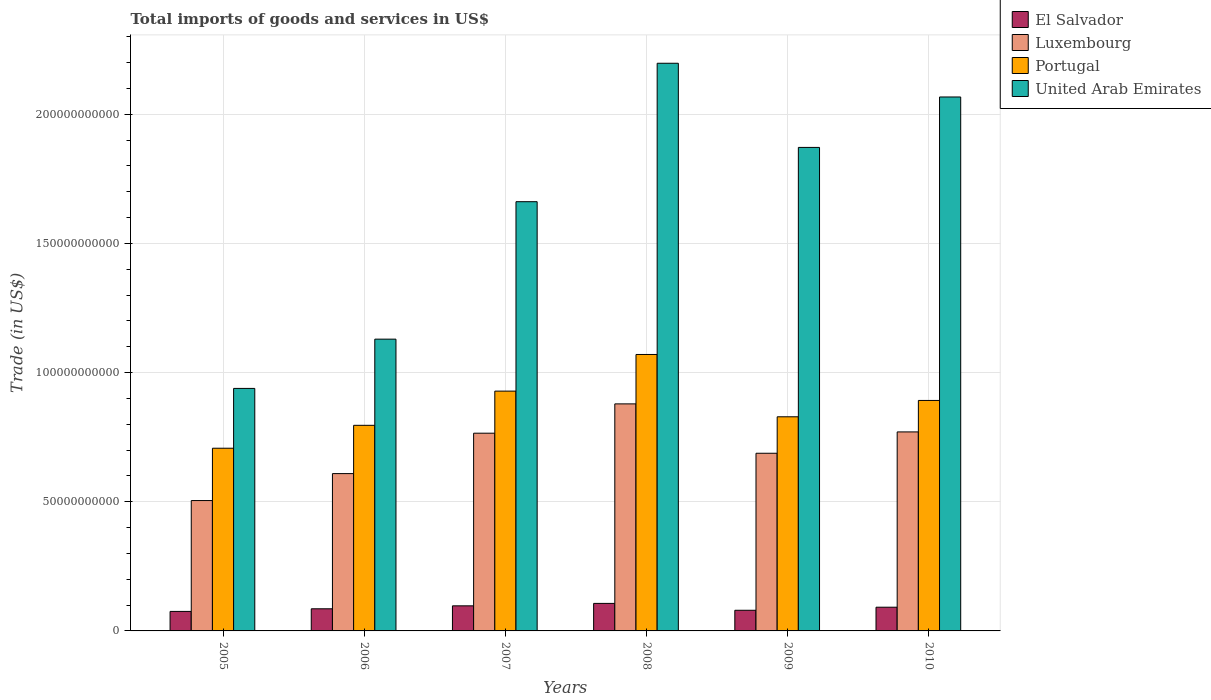How many different coloured bars are there?
Your response must be concise. 4. Are the number of bars per tick equal to the number of legend labels?
Keep it short and to the point. Yes. What is the label of the 4th group of bars from the left?
Ensure brevity in your answer.  2008. What is the total imports of goods and services in United Arab Emirates in 2007?
Offer a terse response. 1.66e+11. Across all years, what is the maximum total imports of goods and services in Luxembourg?
Your answer should be compact. 8.79e+1. Across all years, what is the minimum total imports of goods and services in United Arab Emirates?
Offer a terse response. 9.39e+1. In which year was the total imports of goods and services in United Arab Emirates maximum?
Your answer should be very brief. 2008. In which year was the total imports of goods and services in El Salvador minimum?
Offer a very short reply. 2005. What is the total total imports of goods and services in Luxembourg in the graph?
Provide a short and direct response. 4.22e+11. What is the difference between the total imports of goods and services in United Arab Emirates in 2006 and that in 2007?
Offer a very short reply. -5.32e+1. What is the difference between the total imports of goods and services in Portugal in 2007 and the total imports of goods and services in Luxembourg in 2010?
Offer a very short reply. 1.58e+1. What is the average total imports of goods and services in United Arab Emirates per year?
Provide a short and direct response. 1.64e+11. In the year 2005, what is the difference between the total imports of goods and services in United Arab Emirates and total imports of goods and services in Luxembourg?
Your response must be concise. 4.34e+1. What is the ratio of the total imports of goods and services in Luxembourg in 2009 to that in 2010?
Your answer should be very brief. 0.89. What is the difference between the highest and the second highest total imports of goods and services in Portugal?
Provide a succinct answer. 1.42e+1. What is the difference between the highest and the lowest total imports of goods and services in Luxembourg?
Your response must be concise. 3.74e+1. In how many years, is the total imports of goods and services in United Arab Emirates greater than the average total imports of goods and services in United Arab Emirates taken over all years?
Provide a succinct answer. 4. Is it the case that in every year, the sum of the total imports of goods and services in Portugal and total imports of goods and services in Luxembourg is greater than the sum of total imports of goods and services in El Salvador and total imports of goods and services in United Arab Emirates?
Your response must be concise. No. What does the 4th bar from the left in 2010 represents?
Your answer should be very brief. United Arab Emirates. What does the 2nd bar from the right in 2007 represents?
Give a very brief answer. Portugal. Is it the case that in every year, the sum of the total imports of goods and services in United Arab Emirates and total imports of goods and services in El Salvador is greater than the total imports of goods and services in Portugal?
Provide a short and direct response. Yes. Are all the bars in the graph horizontal?
Your response must be concise. No. What is the difference between two consecutive major ticks on the Y-axis?
Offer a terse response. 5.00e+1. Are the values on the major ticks of Y-axis written in scientific E-notation?
Give a very brief answer. No. Does the graph contain any zero values?
Your response must be concise. No. Does the graph contain grids?
Keep it short and to the point. Yes. How many legend labels are there?
Your answer should be compact. 4. How are the legend labels stacked?
Ensure brevity in your answer.  Vertical. What is the title of the graph?
Give a very brief answer. Total imports of goods and services in US$. Does "Togo" appear as one of the legend labels in the graph?
Provide a succinct answer. No. What is the label or title of the X-axis?
Offer a terse response. Years. What is the label or title of the Y-axis?
Keep it short and to the point. Trade (in US$). What is the Trade (in US$) of El Salvador in 2005?
Your response must be concise. 7.55e+09. What is the Trade (in US$) of Luxembourg in 2005?
Give a very brief answer. 5.05e+1. What is the Trade (in US$) of Portugal in 2005?
Your answer should be compact. 7.07e+1. What is the Trade (in US$) in United Arab Emirates in 2005?
Offer a very short reply. 9.39e+1. What is the Trade (in US$) of El Salvador in 2006?
Make the answer very short. 8.56e+09. What is the Trade (in US$) in Luxembourg in 2006?
Ensure brevity in your answer.  6.09e+1. What is the Trade (in US$) of Portugal in 2006?
Your answer should be very brief. 7.96e+1. What is the Trade (in US$) of United Arab Emirates in 2006?
Ensure brevity in your answer.  1.13e+11. What is the Trade (in US$) of El Salvador in 2007?
Your response must be concise. 9.71e+09. What is the Trade (in US$) in Luxembourg in 2007?
Offer a terse response. 7.65e+1. What is the Trade (in US$) of Portugal in 2007?
Provide a short and direct response. 9.28e+1. What is the Trade (in US$) of United Arab Emirates in 2007?
Offer a terse response. 1.66e+11. What is the Trade (in US$) of El Salvador in 2008?
Give a very brief answer. 1.07e+1. What is the Trade (in US$) in Luxembourg in 2008?
Offer a very short reply. 8.79e+1. What is the Trade (in US$) in Portugal in 2008?
Your answer should be compact. 1.07e+11. What is the Trade (in US$) of United Arab Emirates in 2008?
Provide a succinct answer. 2.20e+11. What is the Trade (in US$) of El Salvador in 2009?
Your answer should be compact. 7.99e+09. What is the Trade (in US$) of Luxembourg in 2009?
Make the answer very short. 6.88e+1. What is the Trade (in US$) of Portugal in 2009?
Give a very brief answer. 8.29e+1. What is the Trade (in US$) of United Arab Emirates in 2009?
Offer a very short reply. 1.87e+11. What is the Trade (in US$) of El Salvador in 2010?
Provide a short and direct response. 9.18e+09. What is the Trade (in US$) in Luxembourg in 2010?
Give a very brief answer. 7.70e+1. What is the Trade (in US$) in Portugal in 2010?
Provide a succinct answer. 8.92e+1. What is the Trade (in US$) of United Arab Emirates in 2010?
Offer a very short reply. 2.07e+11. Across all years, what is the maximum Trade (in US$) of El Salvador?
Give a very brief answer. 1.07e+1. Across all years, what is the maximum Trade (in US$) of Luxembourg?
Give a very brief answer. 8.79e+1. Across all years, what is the maximum Trade (in US$) in Portugal?
Keep it short and to the point. 1.07e+11. Across all years, what is the maximum Trade (in US$) in United Arab Emirates?
Give a very brief answer. 2.20e+11. Across all years, what is the minimum Trade (in US$) in El Salvador?
Your response must be concise. 7.55e+09. Across all years, what is the minimum Trade (in US$) in Luxembourg?
Ensure brevity in your answer.  5.05e+1. Across all years, what is the minimum Trade (in US$) in Portugal?
Provide a succinct answer. 7.07e+1. Across all years, what is the minimum Trade (in US$) of United Arab Emirates?
Provide a short and direct response. 9.39e+1. What is the total Trade (in US$) of El Salvador in the graph?
Provide a short and direct response. 5.36e+1. What is the total Trade (in US$) in Luxembourg in the graph?
Provide a short and direct response. 4.22e+11. What is the total Trade (in US$) in Portugal in the graph?
Provide a short and direct response. 5.22e+11. What is the total Trade (in US$) in United Arab Emirates in the graph?
Provide a succinct answer. 9.86e+11. What is the difference between the Trade (in US$) of El Salvador in 2005 and that in 2006?
Ensure brevity in your answer.  -1.02e+09. What is the difference between the Trade (in US$) of Luxembourg in 2005 and that in 2006?
Provide a succinct answer. -1.04e+1. What is the difference between the Trade (in US$) in Portugal in 2005 and that in 2006?
Your answer should be compact. -8.87e+09. What is the difference between the Trade (in US$) of United Arab Emirates in 2005 and that in 2006?
Give a very brief answer. -1.91e+1. What is the difference between the Trade (in US$) of El Salvador in 2005 and that in 2007?
Your answer should be very brief. -2.16e+09. What is the difference between the Trade (in US$) of Luxembourg in 2005 and that in 2007?
Offer a very short reply. -2.61e+1. What is the difference between the Trade (in US$) in Portugal in 2005 and that in 2007?
Your response must be concise. -2.21e+1. What is the difference between the Trade (in US$) in United Arab Emirates in 2005 and that in 2007?
Keep it short and to the point. -7.23e+1. What is the difference between the Trade (in US$) of El Salvador in 2005 and that in 2008?
Keep it short and to the point. -3.10e+09. What is the difference between the Trade (in US$) in Luxembourg in 2005 and that in 2008?
Make the answer very short. -3.74e+1. What is the difference between the Trade (in US$) in Portugal in 2005 and that in 2008?
Make the answer very short. -3.63e+1. What is the difference between the Trade (in US$) in United Arab Emirates in 2005 and that in 2008?
Provide a short and direct response. -1.26e+11. What is the difference between the Trade (in US$) of El Salvador in 2005 and that in 2009?
Provide a succinct answer. -4.42e+08. What is the difference between the Trade (in US$) in Luxembourg in 2005 and that in 2009?
Your answer should be compact. -1.83e+1. What is the difference between the Trade (in US$) of Portugal in 2005 and that in 2009?
Keep it short and to the point. -1.22e+1. What is the difference between the Trade (in US$) in United Arab Emirates in 2005 and that in 2009?
Your answer should be compact. -9.33e+1. What is the difference between the Trade (in US$) in El Salvador in 2005 and that in 2010?
Offer a terse response. -1.63e+09. What is the difference between the Trade (in US$) in Luxembourg in 2005 and that in 2010?
Keep it short and to the point. -2.66e+1. What is the difference between the Trade (in US$) in Portugal in 2005 and that in 2010?
Make the answer very short. -1.85e+1. What is the difference between the Trade (in US$) in United Arab Emirates in 2005 and that in 2010?
Make the answer very short. -1.13e+11. What is the difference between the Trade (in US$) in El Salvador in 2006 and that in 2007?
Give a very brief answer. -1.15e+09. What is the difference between the Trade (in US$) in Luxembourg in 2006 and that in 2007?
Provide a succinct answer. -1.56e+1. What is the difference between the Trade (in US$) in Portugal in 2006 and that in 2007?
Provide a succinct answer. -1.32e+1. What is the difference between the Trade (in US$) in United Arab Emirates in 2006 and that in 2007?
Provide a short and direct response. -5.32e+1. What is the difference between the Trade (in US$) in El Salvador in 2006 and that in 2008?
Give a very brief answer. -2.09e+09. What is the difference between the Trade (in US$) in Luxembourg in 2006 and that in 2008?
Provide a succinct answer. -2.70e+1. What is the difference between the Trade (in US$) of Portugal in 2006 and that in 2008?
Your answer should be compact. -2.74e+1. What is the difference between the Trade (in US$) of United Arab Emirates in 2006 and that in 2008?
Offer a very short reply. -1.07e+11. What is the difference between the Trade (in US$) in El Salvador in 2006 and that in 2009?
Provide a succinct answer. 5.74e+08. What is the difference between the Trade (in US$) of Luxembourg in 2006 and that in 2009?
Your answer should be very brief. -7.87e+09. What is the difference between the Trade (in US$) in Portugal in 2006 and that in 2009?
Give a very brief answer. -3.30e+09. What is the difference between the Trade (in US$) in United Arab Emirates in 2006 and that in 2009?
Give a very brief answer. -7.42e+1. What is the difference between the Trade (in US$) of El Salvador in 2006 and that in 2010?
Offer a very short reply. -6.12e+08. What is the difference between the Trade (in US$) of Luxembourg in 2006 and that in 2010?
Keep it short and to the point. -1.61e+1. What is the difference between the Trade (in US$) of Portugal in 2006 and that in 2010?
Your answer should be very brief. -9.63e+09. What is the difference between the Trade (in US$) of United Arab Emirates in 2006 and that in 2010?
Your answer should be very brief. -9.37e+1. What is the difference between the Trade (in US$) of El Salvador in 2007 and that in 2008?
Make the answer very short. -9.41e+08. What is the difference between the Trade (in US$) of Luxembourg in 2007 and that in 2008?
Your answer should be very brief. -1.13e+1. What is the difference between the Trade (in US$) of Portugal in 2007 and that in 2008?
Ensure brevity in your answer.  -1.42e+1. What is the difference between the Trade (in US$) in United Arab Emirates in 2007 and that in 2008?
Your answer should be very brief. -5.36e+1. What is the difference between the Trade (in US$) of El Salvador in 2007 and that in 2009?
Keep it short and to the point. 1.72e+09. What is the difference between the Trade (in US$) of Luxembourg in 2007 and that in 2009?
Your answer should be very brief. 7.76e+09. What is the difference between the Trade (in US$) in Portugal in 2007 and that in 2009?
Your response must be concise. 9.94e+09. What is the difference between the Trade (in US$) of United Arab Emirates in 2007 and that in 2009?
Your answer should be very brief. -2.10e+1. What is the difference between the Trade (in US$) in El Salvador in 2007 and that in 2010?
Make the answer very short. 5.33e+08. What is the difference between the Trade (in US$) in Luxembourg in 2007 and that in 2010?
Keep it short and to the point. -4.96e+08. What is the difference between the Trade (in US$) of Portugal in 2007 and that in 2010?
Your answer should be compact. 3.61e+09. What is the difference between the Trade (in US$) in United Arab Emirates in 2007 and that in 2010?
Your answer should be compact. -4.05e+1. What is the difference between the Trade (in US$) of El Salvador in 2008 and that in 2009?
Give a very brief answer. 2.66e+09. What is the difference between the Trade (in US$) in Luxembourg in 2008 and that in 2009?
Provide a succinct answer. 1.91e+1. What is the difference between the Trade (in US$) in Portugal in 2008 and that in 2009?
Your answer should be compact. 2.41e+1. What is the difference between the Trade (in US$) in United Arab Emirates in 2008 and that in 2009?
Your answer should be compact. 3.26e+1. What is the difference between the Trade (in US$) in El Salvador in 2008 and that in 2010?
Your answer should be compact. 1.47e+09. What is the difference between the Trade (in US$) of Luxembourg in 2008 and that in 2010?
Provide a short and direct response. 1.09e+1. What is the difference between the Trade (in US$) in Portugal in 2008 and that in 2010?
Make the answer very short. 1.78e+1. What is the difference between the Trade (in US$) in United Arab Emirates in 2008 and that in 2010?
Provide a short and direct response. 1.31e+1. What is the difference between the Trade (in US$) in El Salvador in 2009 and that in 2010?
Offer a terse response. -1.19e+09. What is the difference between the Trade (in US$) of Luxembourg in 2009 and that in 2010?
Keep it short and to the point. -8.26e+09. What is the difference between the Trade (in US$) in Portugal in 2009 and that in 2010?
Provide a short and direct response. -6.33e+09. What is the difference between the Trade (in US$) of United Arab Emirates in 2009 and that in 2010?
Keep it short and to the point. -1.95e+1. What is the difference between the Trade (in US$) of El Salvador in 2005 and the Trade (in US$) of Luxembourg in 2006?
Your answer should be very brief. -5.33e+1. What is the difference between the Trade (in US$) in El Salvador in 2005 and the Trade (in US$) in Portugal in 2006?
Make the answer very short. -7.20e+1. What is the difference between the Trade (in US$) in El Salvador in 2005 and the Trade (in US$) in United Arab Emirates in 2006?
Make the answer very short. -1.05e+11. What is the difference between the Trade (in US$) of Luxembourg in 2005 and the Trade (in US$) of Portugal in 2006?
Ensure brevity in your answer.  -2.91e+1. What is the difference between the Trade (in US$) in Luxembourg in 2005 and the Trade (in US$) in United Arab Emirates in 2006?
Make the answer very short. -6.25e+1. What is the difference between the Trade (in US$) of Portugal in 2005 and the Trade (in US$) of United Arab Emirates in 2006?
Keep it short and to the point. -4.22e+1. What is the difference between the Trade (in US$) in El Salvador in 2005 and the Trade (in US$) in Luxembourg in 2007?
Offer a very short reply. -6.90e+1. What is the difference between the Trade (in US$) in El Salvador in 2005 and the Trade (in US$) in Portugal in 2007?
Offer a very short reply. -8.53e+1. What is the difference between the Trade (in US$) of El Salvador in 2005 and the Trade (in US$) of United Arab Emirates in 2007?
Your response must be concise. -1.59e+11. What is the difference between the Trade (in US$) of Luxembourg in 2005 and the Trade (in US$) of Portugal in 2007?
Keep it short and to the point. -4.24e+1. What is the difference between the Trade (in US$) in Luxembourg in 2005 and the Trade (in US$) in United Arab Emirates in 2007?
Your answer should be compact. -1.16e+11. What is the difference between the Trade (in US$) of Portugal in 2005 and the Trade (in US$) of United Arab Emirates in 2007?
Your answer should be compact. -9.54e+1. What is the difference between the Trade (in US$) in El Salvador in 2005 and the Trade (in US$) in Luxembourg in 2008?
Provide a succinct answer. -8.03e+1. What is the difference between the Trade (in US$) of El Salvador in 2005 and the Trade (in US$) of Portugal in 2008?
Offer a terse response. -9.94e+1. What is the difference between the Trade (in US$) in El Salvador in 2005 and the Trade (in US$) in United Arab Emirates in 2008?
Give a very brief answer. -2.12e+11. What is the difference between the Trade (in US$) of Luxembourg in 2005 and the Trade (in US$) of Portugal in 2008?
Keep it short and to the point. -5.65e+1. What is the difference between the Trade (in US$) of Luxembourg in 2005 and the Trade (in US$) of United Arab Emirates in 2008?
Provide a short and direct response. -1.69e+11. What is the difference between the Trade (in US$) of Portugal in 2005 and the Trade (in US$) of United Arab Emirates in 2008?
Your answer should be compact. -1.49e+11. What is the difference between the Trade (in US$) of El Salvador in 2005 and the Trade (in US$) of Luxembourg in 2009?
Your answer should be compact. -6.12e+1. What is the difference between the Trade (in US$) of El Salvador in 2005 and the Trade (in US$) of Portugal in 2009?
Offer a very short reply. -7.53e+1. What is the difference between the Trade (in US$) in El Salvador in 2005 and the Trade (in US$) in United Arab Emirates in 2009?
Provide a short and direct response. -1.80e+11. What is the difference between the Trade (in US$) of Luxembourg in 2005 and the Trade (in US$) of Portugal in 2009?
Make the answer very short. -3.24e+1. What is the difference between the Trade (in US$) of Luxembourg in 2005 and the Trade (in US$) of United Arab Emirates in 2009?
Your answer should be compact. -1.37e+11. What is the difference between the Trade (in US$) in Portugal in 2005 and the Trade (in US$) in United Arab Emirates in 2009?
Give a very brief answer. -1.16e+11. What is the difference between the Trade (in US$) in El Salvador in 2005 and the Trade (in US$) in Luxembourg in 2010?
Provide a succinct answer. -6.95e+1. What is the difference between the Trade (in US$) of El Salvador in 2005 and the Trade (in US$) of Portugal in 2010?
Your response must be concise. -8.17e+1. What is the difference between the Trade (in US$) of El Salvador in 2005 and the Trade (in US$) of United Arab Emirates in 2010?
Give a very brief answer. -1.99e+11. What is the difference between the Trade (in US$) in Luxembourg in 2005 and the Trade (in US$) in Portugal in 2010?
Provide a short and direct response. -3.87e+1. What is the difference between the Trade (in US$) of Luxembourg in 2005 and the Trade (in US$) of United Arab Emirates in 2010?
Ensure brevity in your answer.  -1.56e+11. What is the difference between the Trade (in US$) of Portugal in 2005 and the Trade (in US$) of United Arab Emirates in 2010?
Provide a succinct answer. -1.36e+11. What is the difference between the Trade (in US$) in El Salvador in 2006 and the Trade (in US$) in Luxembourg in 2007?
Make the answer very short. -6.80e+1. What is the difference between the Trade (in US$) in El Salvador in 2006 and the Trade (in US$) in Portugal in 2007?
Make the answer very short. -8.43e+1. What is the difference between the Trade (in US$) of El Salvador in 2006 and the Trade (in US$) of United Arab Emirates in 2007?
Keep it short and to the point. -1.58e+11. What is the difference between the Trade (in US$) in Luxembourg in 2006 and the Trade (in US$) in Portugal in 2007?
Keep it short and to the point. -3.19e+1. What is the difference between the Trade (in US$) in Luxembourg in 2006 and the Trade (in US$) in United Arab Emirates in 2007?
Give a very brief answer. -1.05e+11. What is the difference between the Trade (in US$) in Portugal in 2006 and the Trade (in US$) in United Arab Emirates in 2007?
Offer a terse response. -8.66e+1. What is the difference between the Trade (in US$) in El Salvador in 2006 and the Trade (in US$) in Luxembourg in 2008?
Keep it short and to the point. -7.93e+1. What is the difference between the Trade (in US$) of El Salvador in 2006 and the Trade (in US$) of Portugal in 2008?
Make the answer very short. -9.84e+1. What is the difference between the Trade (in US$) in El Salvador in 2006 and the Trade (in US$) in United Arab Emirates in 2008?
Ensure brevity in your answer.  -2.11e+11. What is the difference between the Trade (in US$) in Luxembourg in 2006 and the Trade (in US$) in Portugal in 2008?
Provide a succinct answer. -4.61e+1. What is the difference between the Trade (in US$) of Luxembourg in 2006 and the Trade (in US$) of United Arab Emirates in 2008?
Offer a very short reply. -1.59e+11. What is the difference between the Trade (in US$) in Portugal in 2006 and the Trade (in US$) in United Arab Emirates in 2008?
Keep it short and to the point. -1.40e+11. What is the difference between the Trade (in US$) of El Salvador in 2006 and the Trade (in US$) of Luxembourg in 2009?
Provide a short and direct response. -6.02e+1. What is the difference between the Trade (in US$) of El Salvador in 2006 and the Trade (in US$) of Portugal in 2009?
Give a very brief answer. -7.43e+1. What is the difference between the Trade (in US$) in El Salvador in 2006 and the Trade (in US$) in United Arab Emirates in 2009?
Make the answer very short. -1.79e+11. What is the difference between the Trade (in US$) in Luxembourg in 2006 and the Trade (in US$) in Portugal in 2009?
Ensure brevity in your answer.  -2.20e+1. What is the difference between the Trade (in US$) of Luxembourg in 2006 and the Trade (in US$) of United Arab Emirates in 2009?
Your answer should be very brief. -1.26e+11. What is the difference between the Trade (in US$) in Portugal in 2006 and the Trade (in US$) in United Arab Emirates in 2009?
Provide a succinct answer. -1.08e+11. What is the difference between the Trade (in US$) of El Salvador in 2006 and the Trade (in US$) of Luxembourg in 2010?
Ensure brevity in your answer.  -6.85e+1. What is the difference between the Trade (in US$) of El Salvador in 2006 and the Trade (in US$) of Portugal in 2010?
Provide a succinct answer. -8.06e+1. What is the difference between the Trade (in US$) in El Salvador in 2006 and the Trade (in US$) in United Arab Emirates in 2010?
Offer a terse response. -1.98e+11. What is the difference between the Trade (in US$) of Luxembourg in 2006 and the Trade (in US$) of Portugal in 2010?
Ensure brevity in your answer.  -2.83e+1. What is the difference between the Trade (in US$) of Luxembourg in 2006 and the Trade (in US$) of United Arab Emirates in 2010?
Make the answer very short. -1.46e+11. What is the difference between the Trade (in US$) of Portugal in 2006 and the Trade (in US$) of United Arab Emirates in 2010?
Ensure brevity in your answer.  -1.27e+11. What is the difference between the Trade (in US$) of El Salvador in 2007 and the Trade (in US$) of Luxembourg in 2008?
Make the answer very short. -7.82e+1. What is the difference between the Trade (in US$) in El Salvador in 2007 and the Trade (in US$) in Portugal in 2008?
Your answer should be very brief. -9.73e+1. What is the difference between the Trade (in US$) of El Salvador in 2007 and the Trade (in US$) of United Arab Emirates in 2008?
Offer a terse response. -2.10e+11. What is the difference between the Trade (in US$) of Luxembourg in 2007 and the Trade (in US$) of Portugal in 2008?
Your answer should be very brief. -3.05e+1. What is the difference between the Trade (in US$) of Luxembourg in 2007 and the Trade (in US$) of United Arab Emirates in 2008?
Offer a terse response. -1.43e+11. What is the difference between the Trade (in US$) of Portugal in 2007 and the Trade (in US$) of United Arab Emirates in 2008?
Offer a very short reply. -1.27e+11. What is the difference between the Trade (in US$) of El Salvador in 2007 and the Trade (in US$) of Luxembourg in 2009?
Your answer should be very brief. -5.91e+1. What is the difference between the Trade (in US$) of El Salvador in 2007 and the Trade (in US$) of Portugal in 2009?
Offer a very short reply. -7.32e+1. What is the difference between the Trade (in US$) of El Salvador in 2007 and the Trade (in US$) of United Arab Emirates in 2009?
Your response must be concise. -1.77e+11. What is the difference between the Trade (in US$) in Luxembourg in 2007 and the Trade (in US$) in Portugal in 2009?
Keep it short and to the point. -6.35e+09. What is the difference between the Trade (in US$) of Luxembourg in 2007 and the Trade (in US$) of United Arab Emirates in 2009?
Offer a very short reply. -1.11e+11. What is the difference between the Trade (in US$) of Portugal in 2007 and the Trade (in US$) of United Arab Emirates in 2009?
Offer a terse response. -9.43e+1. What is the difference between the Trade (in US$) of El Salvador in 2007 and the Trade (in US$) of Luxembourg in 2010?
Your answer should be very brief. -6.73e+1. What is the difference between the Trade (in US$) of El Salvador in 2007 and the Trade (in US$) of Portugal in 2010?
Your answer should be compact. -7.95e+1. What is the difference between the Trade (in US$) of El Salvador in 2007 and the Trade (in US$) of United Arab Emirates in 2010?
Provide a short and direct response. -1.97e+11. What is the difference between the Trade (in US$) in Luxembourg in 2007 and the Trade (in US$) in Portugal in 2010?
Keep it short and to the point. -1.27e+1. What is the difference between the Trade (in US$) in Luxembourg in 2007 and the Trade (in US$) in United Arab Emirates in 2010?
Ensure brevity in your answer.  -1.30e+11. What is the difference between the Trade (in US$) of Portugal in 2007 and the Trade (in US$) of United Arab Emirates in 2010?
Provide a succinct answer. -1.14e+11. What is the difference between the Trade (in US$) of El Salvador in 2008 and the Trade (in US$) of Luxembourg in 2009?
Provide a short and direct response. -5.81e+1. What is the difference between the Trade (in US$) of El Salvador in 2008 and the Trade (in US$) of Portugal in 2009?
Provide a succinct answer. -7.22e+1. What is the difference between the Trade (in US$) of El Salvador in 2008 and the Trade (in US$) of United Arab Emirates in 2009?
Make the answer very short. -1.76e+11. What is the difference between the Trade (in US$) of Luxembourg in 2008 and the Trade (in US$) of Portugal in 2009?
Provide a succinct answer. 5.00e+09. What is the difference between the Trade (in US$) of Luxembourg in 2008 and the Trade (in US$) of United Arab Emirates in 2009?
Provide a succinct answer. -9.93e+1. What is the difference between the Trade (in US$) of Portugal in 2008 and the Trade (in US$) of United Arab Emirates in 2009?
Offer a very short reply. -8.01e+1. What is the difference between the Trade (in US$) in El Salvador in 2008 and the Trade (in US$) in Luxembourg in 2010?
Offer a terse response. -6.64e+1. What is the difference between the Trade (in US$) in El Salvador in 2008 and the Trade (in US$) in Portugal in 2010?
Give a very brief answer. -7.86e+1. What is the difference between the Trade (in US$) of El Salvador in 2008 and the Trade (in US$) of United Arab Emirates in 2010?
Offer a terse response. -1.96e+11. What is the difference between the Trade (in US$) in Luxembourg in 2008 and the Trade (in US$) in Portugal in 2010?
Keep it short and to the point. -1.33e+09. What is the difference between the Trade (in US$) of Luxembourg in 2008 and the Trade (in US$) of United Arab Emirates in 2010?
Offer a terse response. -1.19e+11. What is the difference between the Trade (in US$) in Portugal in 2008 and the Trade (in US$) in United Arab Emirates in 2010?
Your response must be concise. -9.97e+1. What is the difference between the Trade (in US$) in El Salvador in 2009 and the Trade (in US$) in Luxembourg in 2010?
Keep it short and to the point. -6.90e+1. What is the difference between the Trade (in US$) in El Salvador in 2009 and the Trade (in US$) in Portugal in 2010?
Make the answer very short. -8.12e+1. What is the difference between the Trade (in US$) in El Salvador in 2009 and the Trade (in US$) in United Arab Emirates in 2010?
Make the answer very short. -1.99e+11. What is the difference between the Trade (in US$) of Luxembourg in 2009 and the Trade (in US$) of Portugal in 2010?
Your answer should be compact. -2.04e+1. What is the difference between the Trade (in US$) in Luxembourg in 2009 and the Trade (in US$) in United Arab Emirates in 2010?
Your response must be concise. -1.38e+11. What is the difference between the Trade (in US$) in Portugal in 2009 and the Trade (in US$) in United Arab Emirates in 2010?
Give a very brief answer. -1.24e+11. What is the average Trade (in US$) of El Salvador per year?
Your answer should be very brief. 8.94e+09. What is the average Trade (in US$) of Luxembourg per year?
Your response must be concise. 7.03e+1. What is the average Trade (in US$) in Portugal per year?
Keep it short and to the point. 8.70e+1. What is the average Trade (in US$) in United Arab Emirates per year?
Offer a terse response. 1.64e+11. In the year 2005, what is the difference between the Trade (in US$) in El Salvador and Trade (in US$) in Luxembourg?
Provide a succinct answer. -4.29e+1. In the year 2005, what is the difference between the Trade (in US$) in El Salvador and Trade (in US$) in Portugal?
Ensure brevity in your answer.  -6.32e+1. In the year 2005, what is the difference between the Trade (in US$) in El Salvador and Trade (in US$) in United Arab Emirates?
Your answer should be compact. -8.63e+1. In the year 2005, what is the difference between the Trade (in US$) in Luxembourg and Trade (in US$) in Portugal?
Keep it short and to the point. -2.02e+1. In the year 2005, what is the difference between the Trade (in US$) of Luxembourg and Trade (in US$) of United Arab Emirates?
Keep it short and to the point. -4.34e+1. In the year 2005, what is the difference between the Trade (in US$) of Portugal and Trade (in US$) of United Arab Emirates?
Your response must be concise. -2.32e+1. In the year 2006, what is the difference between the Trade (in US$) in El Salvador and Trade (in US$) in Luxembourg?
Your answer should be very brief. -5.23e+1. In the year 2006, what is the difference between the Trade (in US$) in El Salvador and Trade (in US$) in Portugal?
Provide a short and direct response. -7.10e+1. In the year 2006, what is the difference between the Trade (in US$) in El Salvador and Trade (in US$) in United Arab Emirates?
Offer a very short reply. -1.04e+11. In the year 2006, what is the difference between the Trade (in US$) of Luxembourg and Trade (in US$) of Portugal?
Ensure brevity in your answer.  -1.87e+1. In the year 2006, what is the difference between the Trade (in US$) of Luxembourg and Trade (in US$) of United Arab Emirates?
Offer a very short reply. -5.20e+1. In the year 2006, what is the difference between the Trade (in US$) of Portugal and Trade (in US$) of United Arab Emirates?
Your answer should be very brief. -3.33e+1. In the year 2007, what is the difference between the Trade (in US$) in El Salvador and Trade (in US$) in Luxembourg?
Give a very brief answer. -6.68e+1. In the year 2007, what is the difference between the Trade (in US$) of El Salvador and Trade (in US$) of Portugal?
Your answer should be compact. -8.31e+1. In the year 2007, what is the difference between the Trade (in US$) of El Salvador and Trade (in US$) of United Arab Emirates?
Your answer should be compact. -1.56e+11. In the year 2007, what is the difference between the Trade (in US$) of Luxembourg and Trade (in US$) of Portugal?
Ensure brevity in your answer.  -1.63e+1. In the year 2007, what is the difference between the Trade (in US$) of Luxembourg and Trade (in US$) of United Arab Emirates?
Your answer should be very brief. -8.96e+1. In the year 2007, what is the difference between the Trade (in US$) of Portugal and Trade (in US$) of United Arab Emirates?
Your response must be concise. -7.33e+1. In the year 2008, what is the difference between the Trade (in US$) in El Salvador and Trade (in US$) in Luxembourg?
Your answer should be compact. -7.72e+1. In the year 2008, what is the difference between the Trade (in US$) of El Salvador and Trade (in US$) of Portugal?
Offer a terse response. -9.63e+1. In the year 2008, what is the difference between the Trade (in US$) of El Salvador and Trade (in US$) of United Arab Emirates?
Your answer should be compact. -2.09e+11. In the year 2008, what is the difference between the Trade (in US$) of Luxembourg and Trade (in US$) of Portugal?
Your answer should be compact. -1.91e+1. In the year 2008, what is the difference between the Trade (in US$) of Luxembourg and Trade (in US$) of United Arab Emirates?
Give a very brief answer. -1.32e+11. In the year 2008, what is the difference between the Trade (in US$) in Portugal and Trade (in US$) in United Arab Emirates?
Offer a very short reply. -1.13e+11. In the year 2009, what is the difference between the Trade (in US$) in El Salvador and Trade (in US$) in Luxembourg?
Ensure brevity in your answer.  -6.08e+1. In the year 2009, what is the difference between the Trade (in US$) of El Salvador and Trade (in US$) of Portugal?
Your response must be concise. -7.49e+1. In the year 2009, what is the difference between the Trade (in US$) in El Salvador and Trade (in US$) in United Arab Emirates?
Your answer should be very brief. -1.79e+11. In the year 2009, what is the difference between the Trade (in US$) of Luxembourg and Trade (in US$) of Portugal?
Keep it short and to the point. -1.41e+1. In the year 2009, what is the difference between the Trade (in US$) in Luxembourg and Trade (in US$) in United Arab Emirates?
Provide a short and direct response. -1.18e+11. In the year 2009, what is the difference between the Trade (in US$) of Portugal and Trade (in US$) of United Arab Emirates?
Your answer should be compact. -1.04e+11. In the year 2010, what is the difference between the Trade (in US$) in El Salvador and Trade (in US$) in Luxembourg?
Keep it short and to the point. -6.78e+1. In the year 2010, what is the difference between the Trade (in US$) in El Salvador and Trade (in US$) in Portugal?
Ensure brevity in your answer.  -8.00e+1. In the year 2010, what is the difference between the Trade (in US$) in El Salvador and Trade (in US$) in United Arab Emirates?
Your answer should be compact. -1.97e+11. In the year 2010, what is the difference between the Trade (in US$) of Luxembourg and Trade (in US$) of Portugal?
Provide a succinct answer. -1.22e+1. In the year 2010, what is the difference between the Trade (in US$) in Luxembourg and Trade (in US$) in United Arab Emirates?
Your answer should be very brief. -1.30e+11. In the year 2010, what is the difference between the Trade (in US$) of Portugal and Trade (in US$) of United Arab Emirates?
Your answer should be compact. -1.17e+11. What is the ratio of the Trade (in US$) in El Salvador in 2005 to that in 2006?
Offer a very short reply. 0.88. What is the ratio of the Trade (in US$) of Luxembourg in 2005 to that in 2006?
Give a very brief answer. 0.83. What is the ratio of the Trade (in US$) of Portugal in 2005 to that in 2006?
Your answer should be very brief. 0.89. What is the ratio of the Trade (in US$) of United Arab Emirates in 2005 to that in 2006?
Your answer should be compact. 0.83. What is the ratio of the Trade (in US$) of El Salvador in 2005 to that in 2007?
Your answer should be compact. 0.78. What is the ratio of the Trade (in US$) of Luxembourg in 2005 to that in 2007?
Ensure brevity in your answer.  0.66. What is the ratio of the Trade (in US$) in Portugal in 2005 to that in 2007?
Your response must be concise. 0.76. What is the ratio of the Trade (in US$) in United Arab Emirates in 2005 to that in 2007?
Keep it short and to the point. 0.56. What is the ratio of the Trade (in US$) of El Salvador in 2005 to that in 2008?
Ensure brevity in your answer.  0.71. What is the ratio of the Trade (in US$) of Luxembourg in 2005 to that in 2008?
Make the answer very short. 0.57. What is the ratio of the Trade (in US$) of Portugal in 2005 to that in 2008?
Make the answer very short. 0.66. What is the ratio of the Trade (in US$) in United Arab Emirates in 2005 to that in 2008?
Provide a succinct answer. 0.43. What is the ratio of the Trade (in US$) of El Salvador in 2005 to that in 2009?
Provide a short and direct response. 0.94. What is the ratio of the Trade (in US$) of Luxembourg in 2005 to that in 2009?
Make the answer very short. 0.73. What is the ratio of the Trade (in US$) in Portugal in 2005 to that in 2009?
Provide a succinct answer. 0.85. What is the ratio of the Trade (in US$) of United Arab Emirates in 2005 to that in 2009?
Provide a succinct answer. 0.5. What is the ratio of the Trade (in US$) of El Salvador in 2005 to that in 2010?
Give a very brief answer. 0.82. What is the ratio of the Trade (in US$) of Luxembourg in 2005 to that in 2010?
Give a very brief answer. 0.66. What is the ratio of the Trade (in US$) of Portugal in 2005 to that in 2010?
Offer a very short reply. 0.79. What is the ratio of the Trade (in US$) in United Arab Emirates in 2005 to that in 2010?
Offer a very short reply. 0.45. What is the ratio of the Trade (in US$) in El Salvador in 2006 to that in 2007?
Your answer should be compact. 0.88. What is the ratio of the Trade (in US$) of Luxembourg in 2006 to that in 2007?
Give a very brief answer. 0.8. What is the ratio of the Trade (in US$) of Portugal in 2006 to that in 2007?
Your answer should be very brief. 0.86. What is the ratio of the Trade (in US$) in United Arab Emirates in 2006 to that in 2007?
Provide a succinct answer. 0.68. What is the ratio of the Trade (in US$) of El Salvador in 2006 to that in 2008?
Keep it short and to the point. 0.8. What is the ratio of the Trade (in US$) of Luxembourg in 2006 to that in 2008?
Provide a succinct answer. 0.69. What is the ratio of the Trade (in US$) of Portugal in 2006 to that in 2008?
Make the answer very short. 0.74. What is the ratio of the Trade (in US$) in United Arab Emirates in 2006 to that in 2008?
Offer a very short reply. 0.51. What is the ratio of the Trade (in US$) in El Salvador in 2006 to that in 2009?
Provide a short and direct response. 1.07. What is the ratio of the Trade (in US$) of Luxembourg in 2006 to that in 2009?
Make the answer very short. 0.89. What is the ratio of the Trade (in US$) in Portugal in 2006 to that in 2009?
Provide a succinct answer. 0.96. What is the ratio of the Trade (in US$) in United Arab Emirates in 2006 to that in 2009?
Make the answer very short. 0.6. What is the ratio of the Trade (in US$) in Luxembourg in 2006 to that in 2010?
Keep it short and to the point. 0.79. What is the ratio of the Trade (in US$) of Portugal in 2006 to that in 2010?
Provide a succinct answer. 0.89. What is the ratio of the Trade (in US$) in United Arab Emirates in 2006 to that in 2010?
Your answer should be compact. 0.55. What is the ratio of the Trade (in US$) in El Salvador in 2007 to that in 2008?
Offer a very short reply. 0.91. What is the ratio of the Trade (in US$) in Luxembourg in 2007 to that in 2008?
Make the answer very short. 0.87. What is the ratio of the Trade (in US$) in Portugal in 2007 to that in 2008?
Make the answer very short. 0.87. What is the ratio of the Trade (in US$) of United Arab Emirates in 2007 to that in 2008?
Your answer should be compact. 0.76. What is the ratio of the Trade (in US$) in El Salvador in 2007 to that in 2009?
Provide a short and direct response. 1.22. What is the ratio of the Trade (in US$) in Luxembourg in 2007 to that in 2009?
Your response must be concise. 1.11. What is the ratio of the Trade (in US$) of Portugal in 2007 to that in 2009?
Offer a very short reply. 1.12. What is the ratio of the Trade (in US$) in United Arab Emirates in 2007 to that in 2009?
Provide a short and direct response. 0.89. What is the ratio of the Trade (in US$) in El Salvador in 2007 to that in 2010?
Ensure brevity in your answer.  1.06. What is the ratio of the Trade (in US$) in Portugal in 2007 to that in 2010?
Your answer should be compact. 1.04. What is the ratio of the Trade (in US$) in United Arab Emirates in 2007 to that in 2010?
Offer a very short reply. 0.8. What is the ratio of the Trade (in US$) of El Salvador in 2008 to that in 2009?
Give a very brief answer. 1.33. What is the ratio of the Trade (in US$) of Luxembourg in 2008 to that in 2009?
Keep it short and to the point. 1.28. What is the ratio of the Trade (in US$) of Portugal in 2008 to that in 2009?
Provide a succinct answer. 1.29. What is the ratio of the Trade (in US$) in United Arab Emirates in 2008 to that in 2009?
Offer a terse response. 1.17. What is the ratio of the Trade (in US$) in El Salvador in 2008 to that in 2010?
Ensure brevity in your answer.  1.16. What is the ratio of the Trade (in US$) of Luxembourg in 2008 to that in 2010?
Make the answer very short. 1.14. What is the ratio of the Trade (in US$) in Portugal in 2008 to that in 2010?
Make the answer very short. 1.2. What is the ratio of the Trade (in US$) of United Arab Emirates in 2008 to that in 2010?
Offer a terse response. 1.06. What is the ratio of the Trade (in US$) in El Salvador in 2009 to that in 2010?
Provide a succinct answer. 0.87. What is the ratio of the Trade (in US$) of Luxembourg in 2009 to that in 2010?
Ensure brevity in your answer.  0.89. What is the ratio of the Trade (in US$) in Portugal in 2009 to that in 2010?
Provide a succinct answer. 0.93. What is the ratio of the Trade (in US$) of United Arab Emirates in 2009 to that in 2010?
Give a very brief answer. 0.91. What is the difference between the highest and the second highest Trade (in US$) of El Salvador?
Make the answer very short. 9.41e+08. What is the difference between the highest and the second highest Trade (in US$) in Luxembourg?
Your response must be concise. 1.09e+1. What is the difference between the highest and the second highest Trade (in US$) in Portugal?
Offer a terse response. 1.42e+1. What is the difference between the highest and the second highest Trade (in US$) of United Arab Emirates?
Your response must be concise. 1.31e+1. What is the difference between the highest and the lowest Trade (in US$) of El Salvador?
Offer a very short reply. 3.10e+09. What is the difference between the highest and the lowest Trade (in US$) of Luxembourg?
Make the answer very short. 3.74e+1. What is the difference between the highest and the lowest Trade (in US$) of Portugal?
Make the answer very short. 3.63e+1. What is the difference between the highest and the lowest Trade (in US$) in United Arab Emirates?
Your answer should be compact. 1.26e+11. 